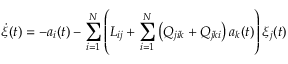<formula> <loc_0><loc_0><loc_500><loc_500>\dot { \xi } ( t ) = - a _ { i } ( t ) - \sum _ { i = 1 } ^ { N } \left ( { L } _ { i j } + \sum _ { i = 1 } ^ { N } \left ( Q _ { j i k } + Q _ { j k i } \right ) a _ { k } ( t ) \right ) \xi _ { j } ( t )</formula> 